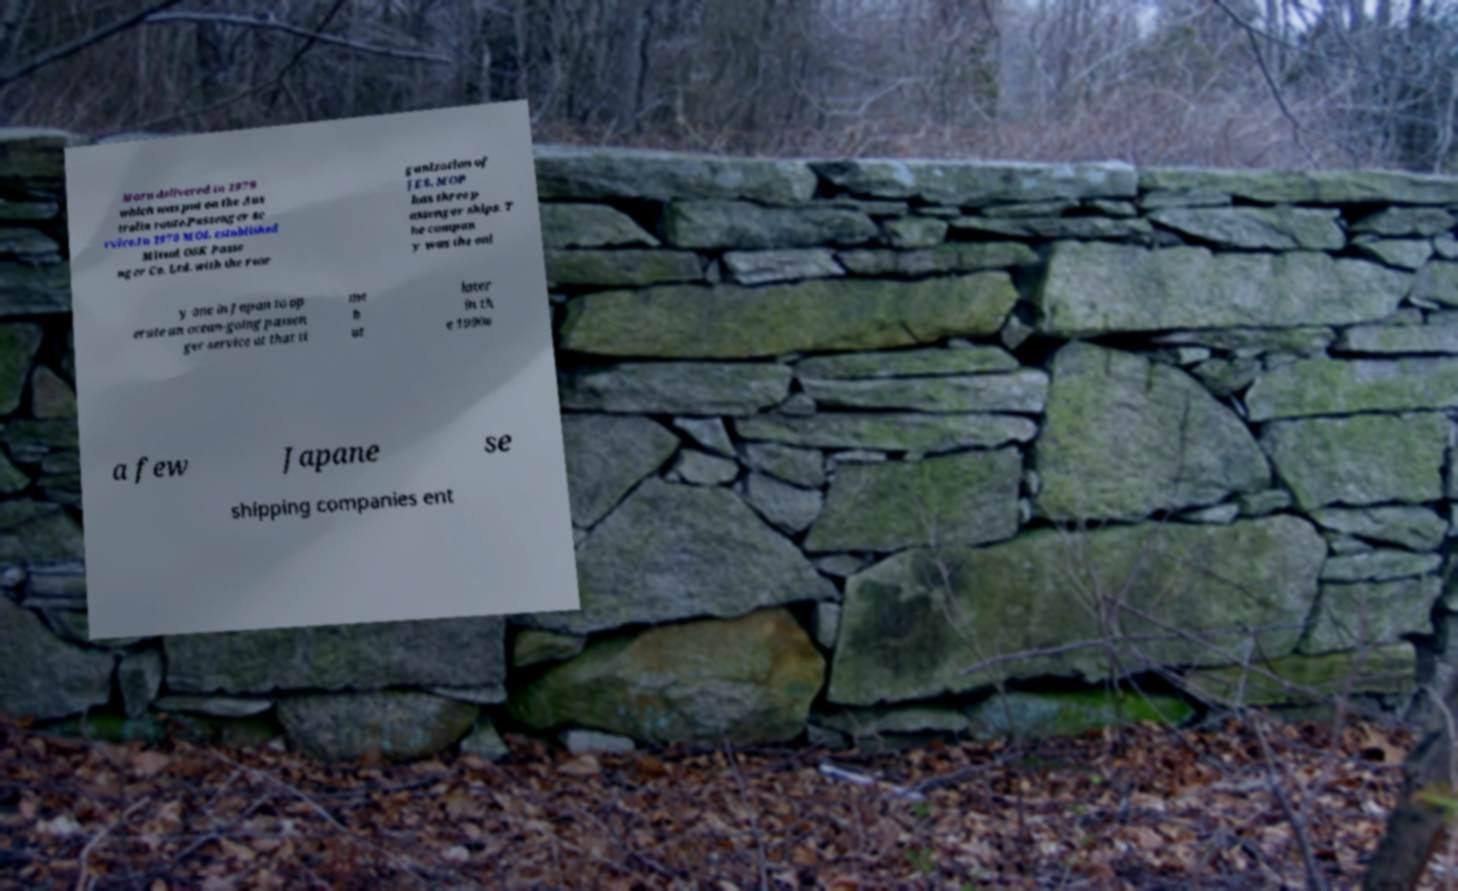Please identify and transcribe the text found in this image. Maru delivered in 1979 which was put on the Aus tralia route.Passenger se rvice.In 1970 MOL established Mitsui OSK Passe nger Co. Ltd. with the reor ganization of JES. MOP has three p assenger ships. T he compan y was the onl y one in Japan to op erate an ocean-going passen ger service at that ti me b ut later in th e 1990s a few Japane se shipping companies ent 